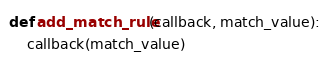Convert code to text. <code><loc_0><loc_0><loc_500><loc_500><_Python_>def add_match_rule(callback, match_value):
    callback(match_value)
</code> 